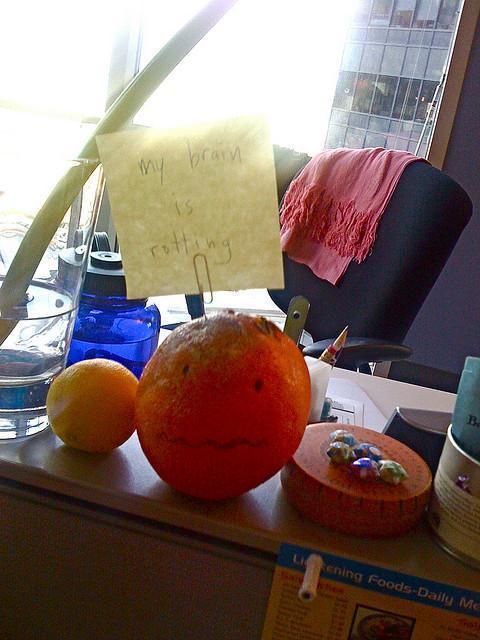How many oranges are visible?
Give a very brief answer. 2. How many chairs are in the photo?
Give a very brief answer. 1. How many men are playing catcher?
Give a very brief answer. 0. 